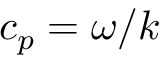Convert formula to latex. <formula><loc_0><loc_0><loc_500><loc_500>c _ { p } = \omega / k</formula> 